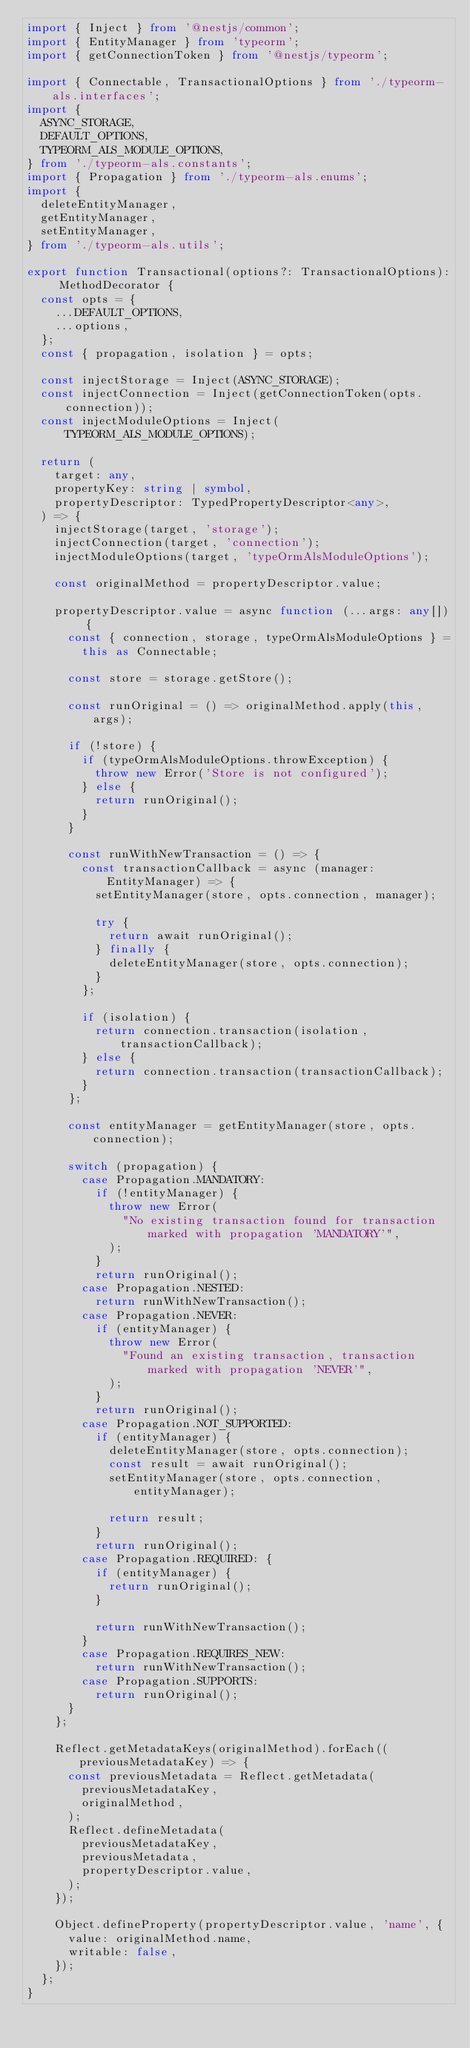Convert code to text. <code><loc_0><loc_0><loc_500><loc_500><_TypeScript_>import { Inject } from '@nestjs/common';
import { EntityManager } from 'typeorm';
import { getConnectionToken } from '@nestjs/typeorm';

import { Connectable, TransactionalOptions } from './typeorm-als.interfaces';
import {
  ASYNC_STORAGE,
  DEFAULT_OPTIONS,
  TYPEORM_ALS_MODULE_OPTIONS,
} from './typeorm-als.constants';
import { Propagation } from './typeorm-als.enums';
import {
  deleteEntityManager,
  getEntityManager,
  setEntityManager,
} from './typeorm-als.utils';

export function Transactional(options?: TransactionalOptions): MethodDecorator {
  const opts = {
    ...DEFAULT_OPTIONS,
    ...options,
  };
  const { propagation, isolation } = opts;

  const injectStorage = Inject(ASYNC_STORAGE);
  const injectConnection = Inject(getConnectionToken(opts.connection));
  const injectModuleOptions = Inject(TYPEORM_ALS_MODULE_OPTIONS);

  return (
    target: any,
    propertyKey: string | symbol,
    propertyDescriptor: TypedPropertyDescriptor<any>,
  ) => {
    injectStorage(target, 'storage');
    injectConnection(target, 'connection');
    injectModuleOptions(target, 'typeOrmAlsModuleOptions');

    const originalMethod = propertyDescriptor.value;

    propertyDescriptor.value = async function (...args: any[]) {
      const { connection, storage, typeOrmAlsModuleOptions } =
        this as Connectable;

      const store = storage.getStore();

      const runOriginal = () => originalMethod.apply(this, args);

      if (!store) {
        if (typeOrmAlsModuleOptions.throwException) {
          throw new Error('Store is not configured');
        } else {
          return runOriginal();
        }
      }

      const runWithNewTransaction = () => {
        const transactionCallback = async (manager: EntityManager) => {
          setEntityManager(store, opts.connection, manager);

          try {
            return await runOriginal();
          } finally {
            deleteEntityManager(store, opts.connection);
          }
        };

        if (isolation) {
          return connection.transaction(isolation, transactionCallback);
        } else {
          return connection.transaction(transactionCallback);
        }
      };

      const entityManager = getEntityManager(store, opts.connection);

      switch (propagation) {
        case Propagation.MANDATORY:
          if (!entityManager) {
            throw new Error(
              "No existing transaction found for transaction marked with propagation 'MANDATORY'",
            );
          }
          return runOriginal();
        case Propagation.NESTED:
          return runWithNewTransaction();
        case Propagation.NEVER:
          if (entityManager) {
            throw new Error(
              "Found an existing transaction, transaction marked with propagation 'NEVER'",
            );
          }
          return runOriginal();
        case Propagation.NOT_SUPPORTED:
          if (entityManager) {
            deleteEntityManager(store, opts.connection);
            const result = await runOriginal();
            setEntityManager(store, opts.connection, entityManager);

            return result;
          }
          return runOriginal();
        case Propagation.REQUIRED: {
          if (entityManager) {
            return runOriginal();
          }

          return runWithNewTransaction();
        }
        case Propagation.REQUIRES_NEW:
          return runWithNewTransaction();
        case Propagation.SUPPORTS:
          return runOriginal();
      }
    };

    Reflect.getMetadataKeys(originalMethod).forEach((previousMetadataKey) => {
      const previousMetadata = Reflect.getMetadata(
        previousMetadataKey,
        originalMethod,
      );
      Reflect.defineMetadata(
        previousMetadataKey,
        previousMetadata,
        propertyDescriptor.value,
      );
    });

    Object.defineProperty(propertyDescriptor.value, 'name', {
      value: originalMethod.name,
      writable: false,
    });
  };
}
</code> 